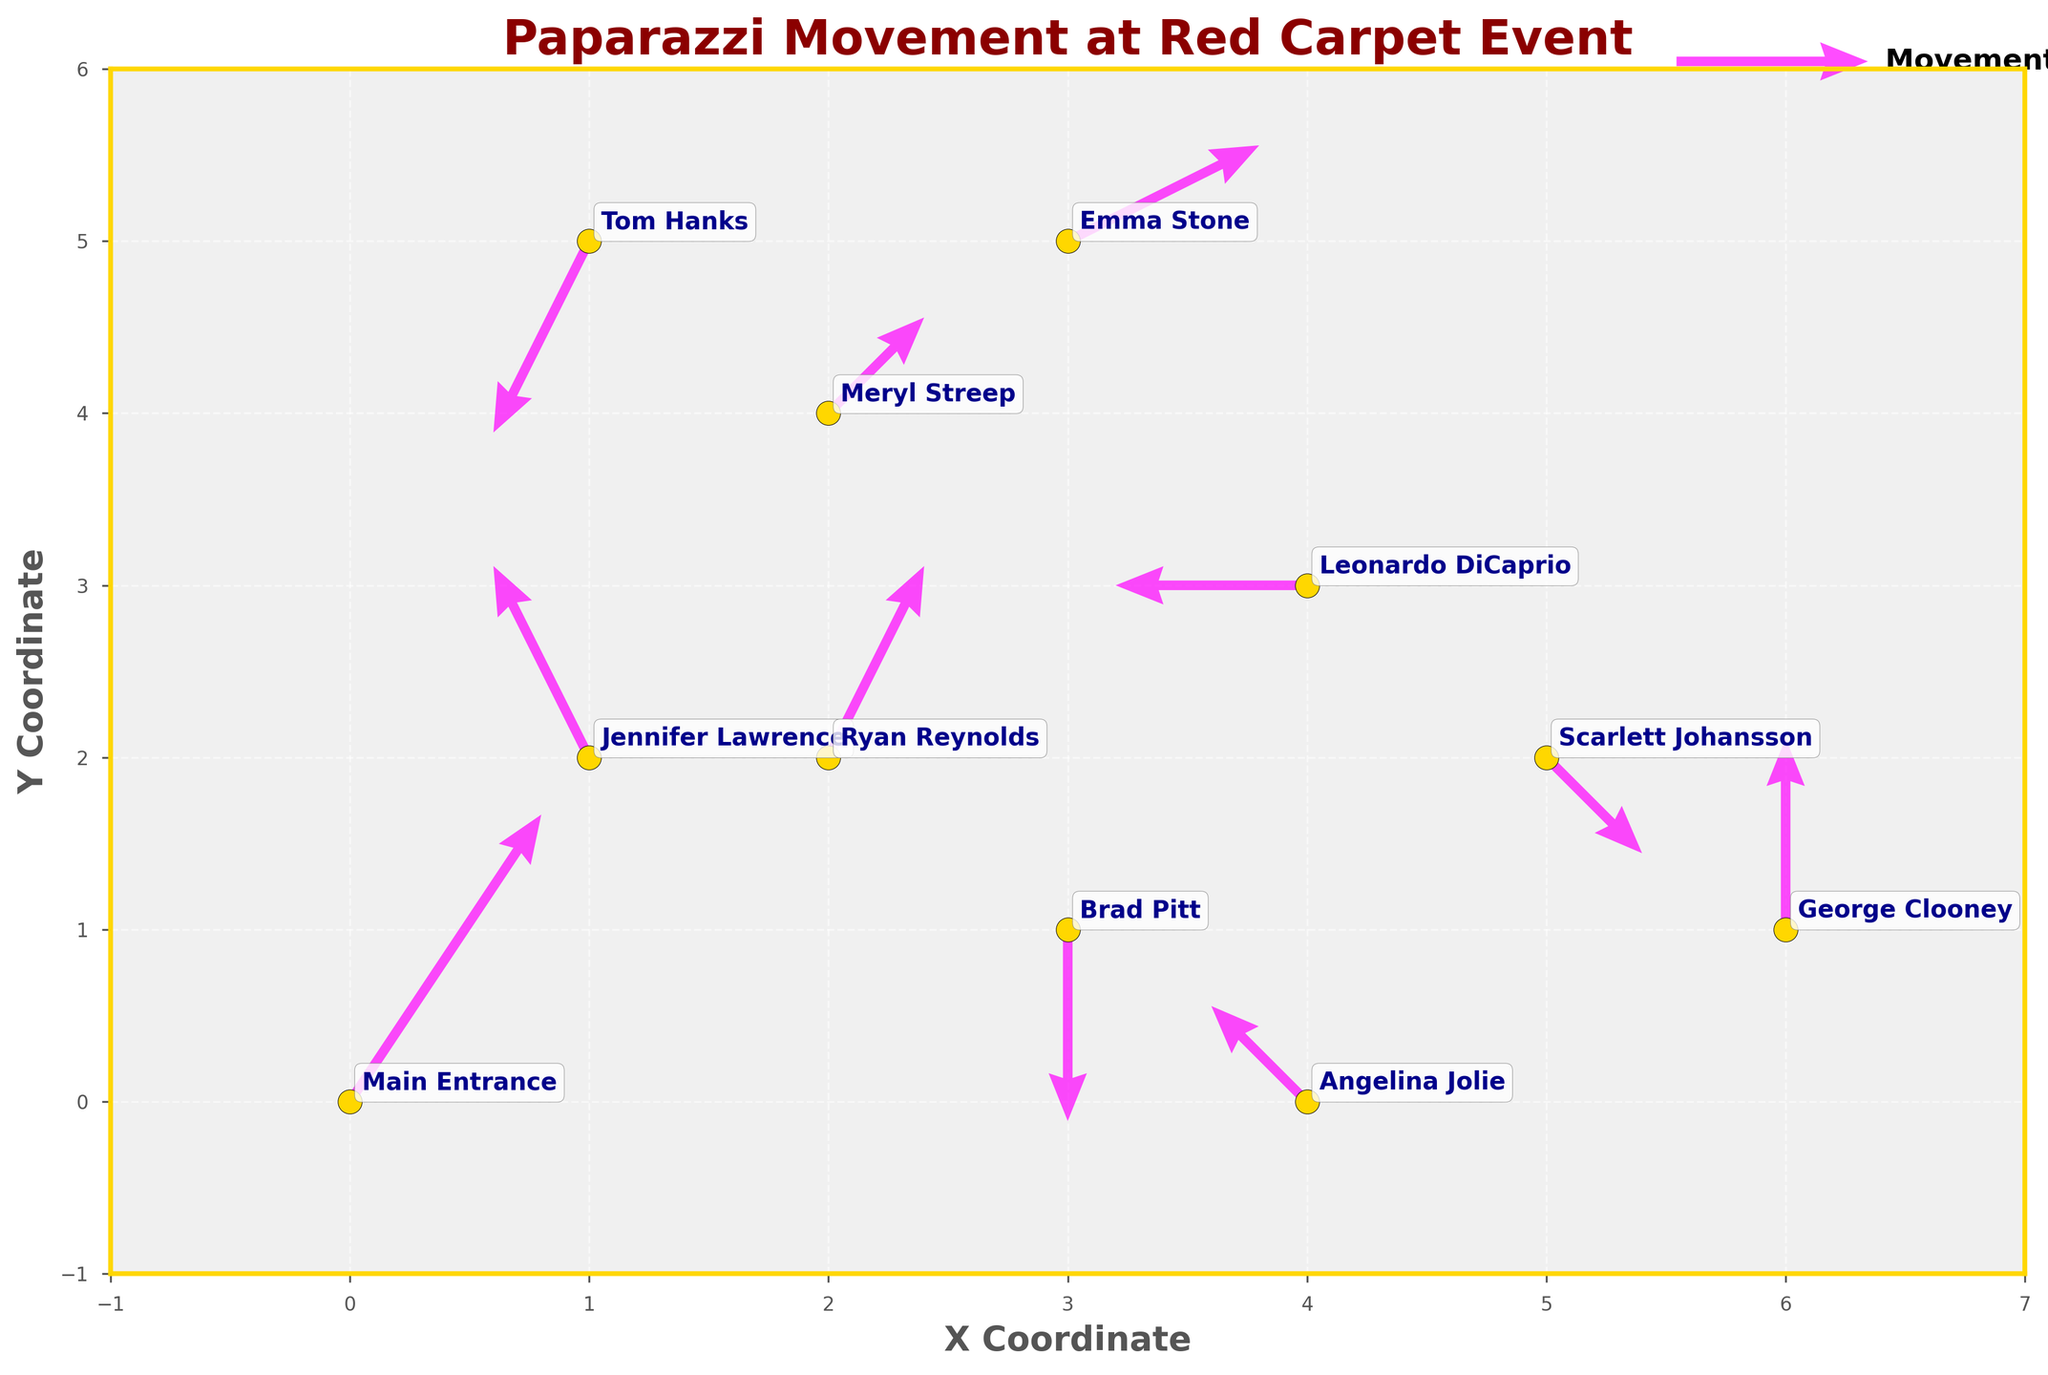What is the title of the plot? The title is usually found at the top of the plot, providing a brief description. It reads, "Paparazzi Movement at Red Carpet Event" which clearly indicates the focus of the visual.
Answer: Paparazzi Movement at Red Carpet Event How many data points are there in the plot? By counting the unique labels or points marked with annotations, we can see that there are 11 data points in the plot.
Answer: 11 Which direction is Leonardo DiCaprio moving? Looking at Leonardo DiCaprio's quiver, which is centered at (4,3) with an arrow pointing to the left horizontally, it indicates no vertical movement.
Answer: Left Which individual has the largest vertical movement? Examining the lengths in the vertical direction (v component) in the quiver plot, we see Jennifer Lawrence at (1,2) has a vertical movement of 2, equal to George Clooney at (6,1), but she appears first in the list.
Answer: Jennifer Lawrence Who has movement starting from coordinates (5,2)? By checking the coordinates where movements originate, we see that movement from (5,2) is associated with Scarlett Johansson.
Answer: Scarlett Johansson How many people are moving leftward? By analyzing the u components of movement vectors, values less than 0 indicate leftward movement. We can count that Jennifer Lawrence, Leonardo DiCaprio, Tom Hanks, and Angelina Jolie (4) are leftward movers.
Answer: 4 Who is moving the shortest distance? The shortest distance can be deduced by the smallest magnitude of vectors (u^2 + v^2)^0.5. Brad Pitt's vector (0,-2) translates to a distance of sqrt(0+4)=2.
Answer: Brad Pitt Which person is closest to the main entrance? Observing the Euclidean distance from (0,0) where Main Entrance is located, excluding the entrance itself, Ryan Reynolds at (2,2) appears closest with a distance of sqrt(2^2+2^2)=sqrt(8).
Answer: Ryan Reynolds What is the average vertical movement? Summing up all the vertical components (3, 2, -2, 1, 0, -1, -2, 1, 2, 1, 2) gives 7 which when divided by the count of 11 yields approximately 0.64.
Answer: 0.64 Which direction is Jennifer Lawrence moving? Observing the quiver details for Jennifer Lawrence at (1,2), the arrow points left and upward, suggesting she is moving leftward and upward.
Answer: Leftward and Upward 